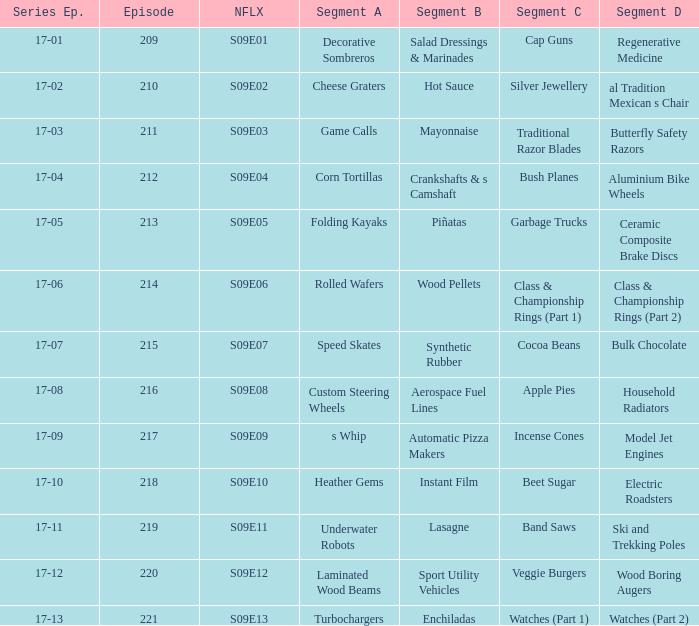Segment A of heather gems is what netflix episode? S09E10. 